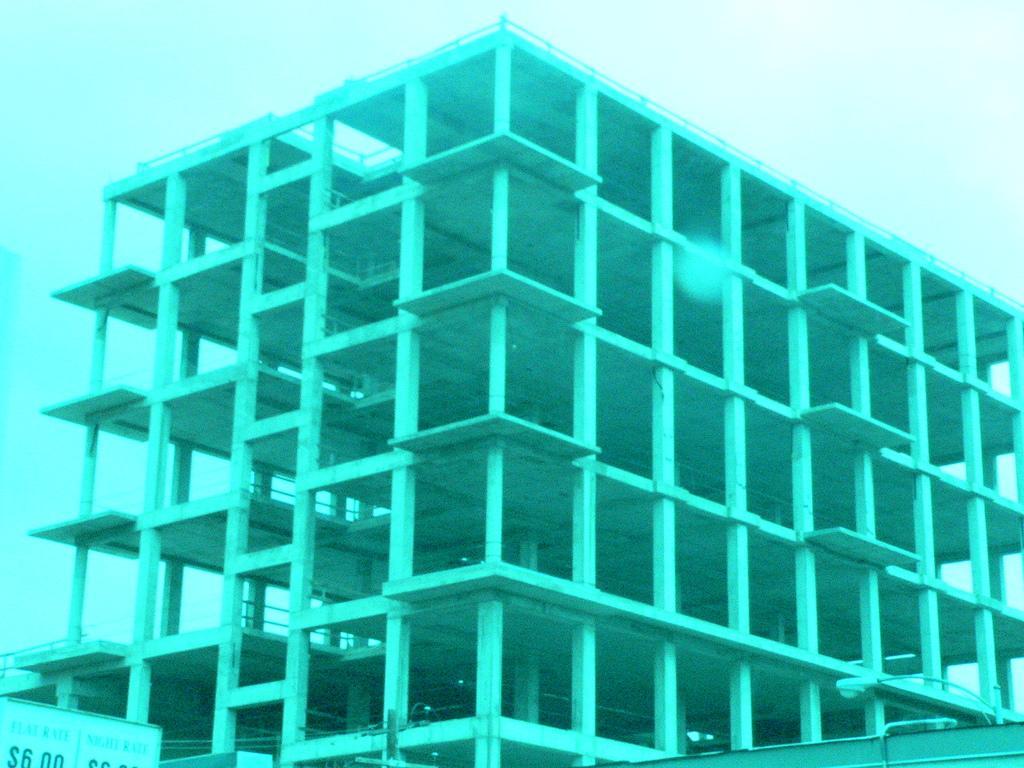In one or two sentences, can you explain what this image depicts? In the center of the image there is a building. At the top of the image there is sky. 